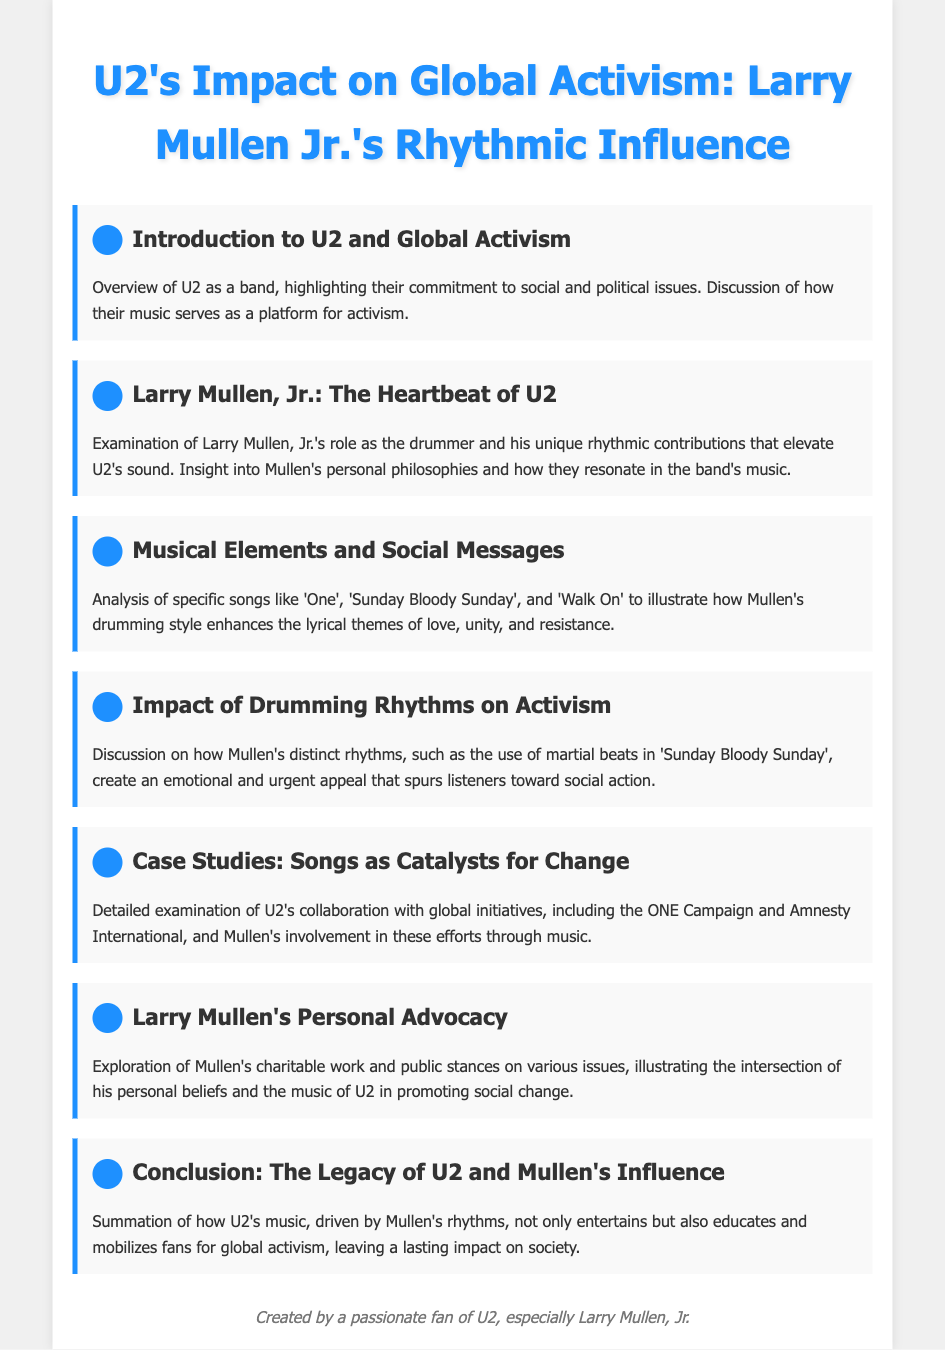What is the title of the document? The title of the document is prominently displayed at the top of the page in the header section.
Answer: U2's Impact on Global Activism: Larry Mullen Jr.'s Rhythmic Influence Who is the focus of the second agenda item? The second agenda item emphasizes the contributions of a specific band member, which is mentioned in the title of that section.
Answer: Larry Mullen, Jr What song is mentioned as having martial beats? The discussion on drumming rhythms highlights a specific song in this context that contains martial beats.
Answer: Sunday Bloody Sunday What campaign is mentioned in the case studies section? One of the collaborations discussed in the case studies is noted for its global outreach and activism efforts.
Answer: ONE Campaign What themes are analyzed in the musical elements agenda item? The agenda item focuses on how specific themes expressed in U2's iconic songs are portrayed, showcasing a range of human emotions and responses.
Answer: love, unity, and resistance Which personal beliefs of Mullen's are explored? The agenda item discusses how Mullen's personal values connect to broader themes of charity and advocacy within U2's music.
Answer: charitable work and public stances What type of music did U2 use to elevate their activism message? The document emphasizes the critical connection between a specific musical style and its impact on social engagements through the band's work.
Answer: rhythms What is the concluding focus of the agenda? The document's conclusion summarizes the overall impact of the band and its drummer on social change and music.
Answer: The Legacy of U2 and Mullen's Influence What is highlighted in the introduction section? The introduction sets the stage for understanding the broader implications of the band's music, specifically regarding societal concerns.
Answer: commitment to social and political issues 